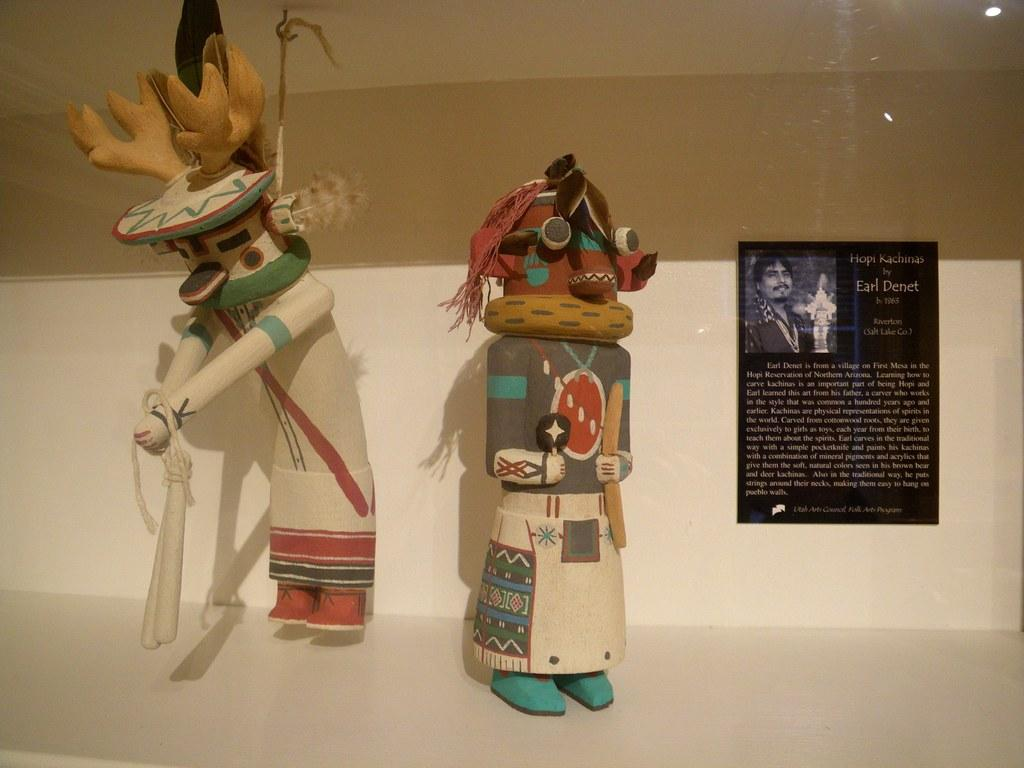What is placed on the floor in the image? There are dolls placed on the floor. What can be seen hanging on the wall in the image? There is a wall hanging in the image. What type of ant can be seen crawling on the dolls in the image? There are no ants present in the image; it only features dolls placed on the floor and a wall hanging. 